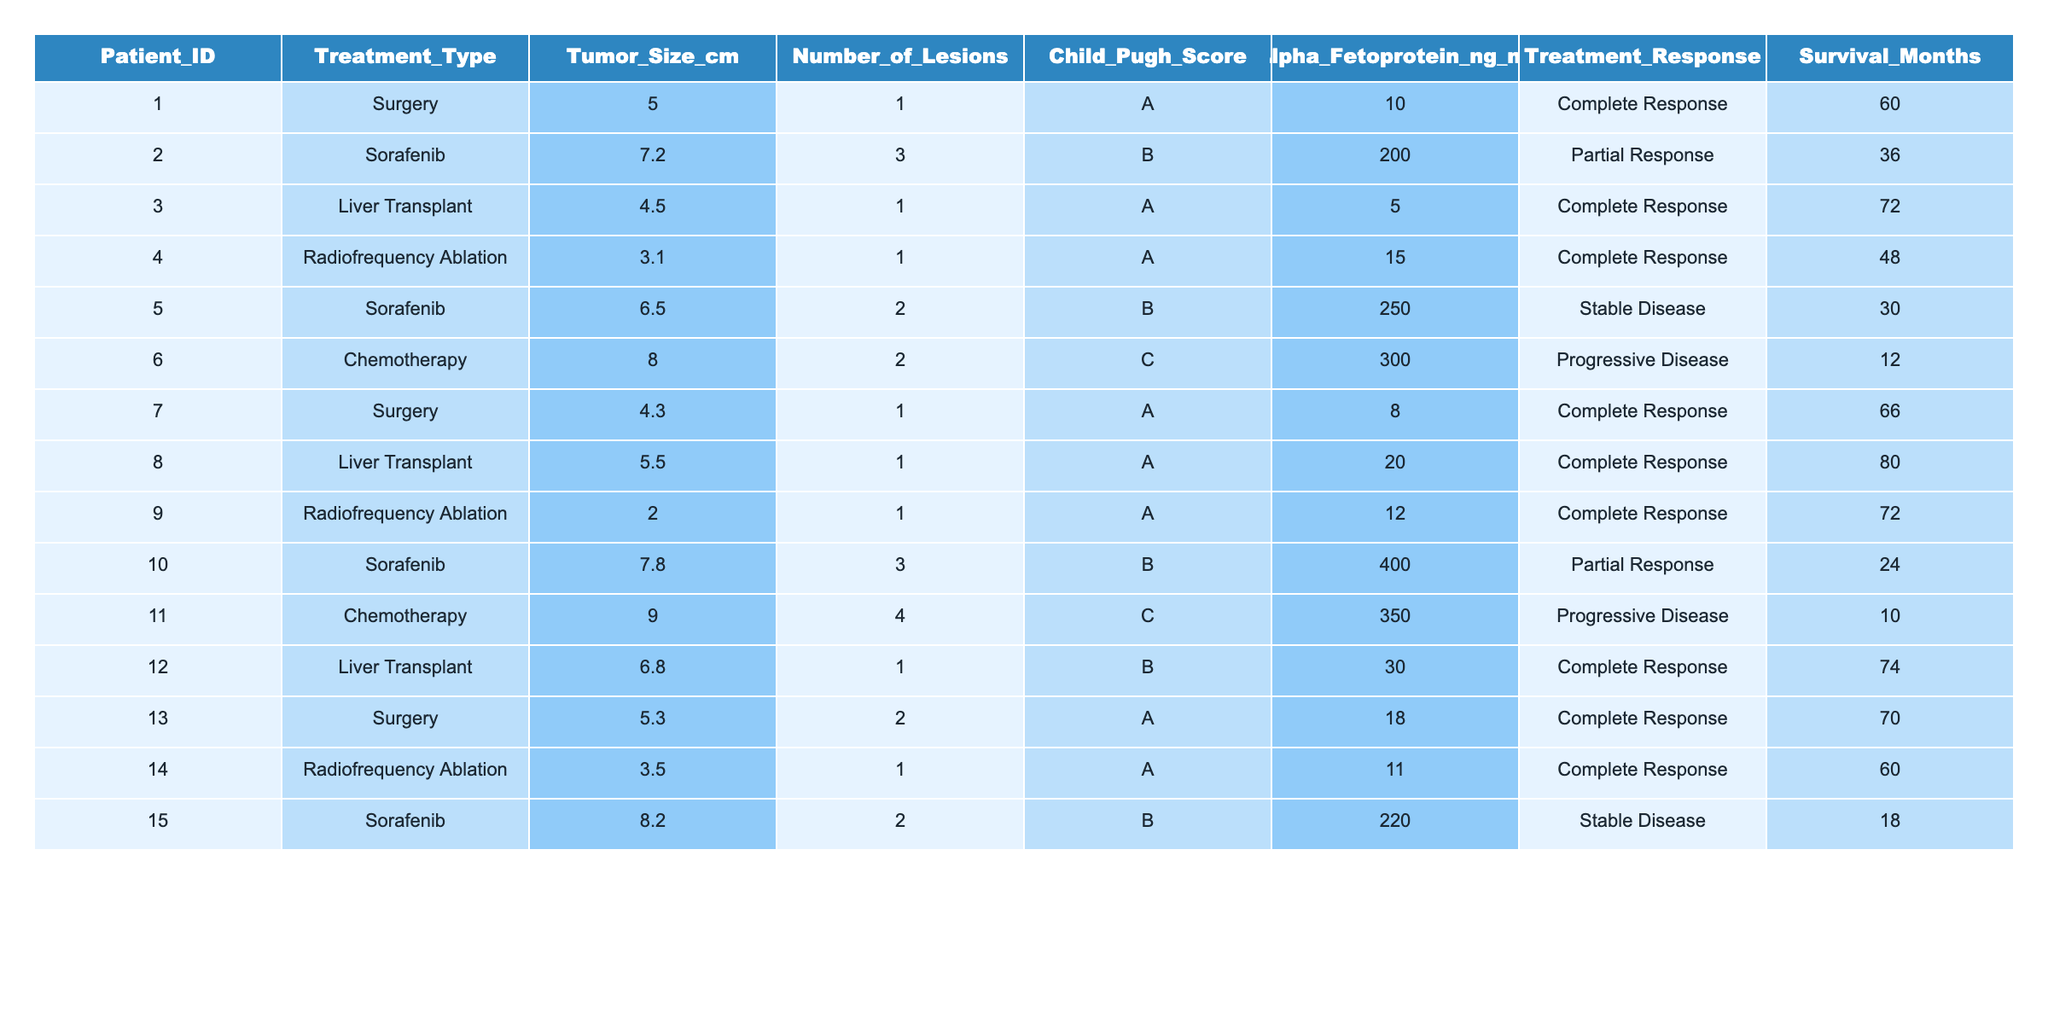What is the treatment response for Patient_ID 5? By looking at the table, I found Patient_ID 5 has a Treatment_Response listed as "Stable Disease."
Answer: Stable Disease How many patients received a liver transplant? The table shows that there are 4 entries for patients receiving "Liver Transplant" as their Treatment_Type.
Answer: 4 What is the average survival time for patients who underwent surgery? The patients who underwent surgery are identified: Patient_IDs 1, 2, 7, and 13 with survival months of 60, 36, 66, and 70 respectively. Summing these gives 60 + 36 + 66 + 70 = 232. Then, dividing by 4 (number of surgical patients) results in an average of 58.
Answer: 58 Did any patients with a Child-Pugh Score of C achieve a complete response? By examining the data in the table, I find that both patients with a Child-Pugh Score of C (Patient_IDs 6 and 11) have a Treatment_Response of "Progressive Disease," thus confirming no complete responses exist for this score.
Answer: No What is the total number of lesions among patients who received chemotherapy? The table indicates patients with chemotherapy are Patient_IDs 6 and 11, with their Number_of_Lesions recorded as 2 and 4, respectively. Summing these gives 2 + 4 = 6.
Answer: 6 Which treatment type yields the highest average survival months, and what is that average? From the table, we calculate the average survival months for each treatment type: Surgery: (60 + 66 + 70) / 3 = 65; Sorafenib: (36 + 30 + 24 + 18) / 4 = 27; Liver Transplant: (72 + 80 + 74) / 3 = 75. Radiofrequency Ablation: (48 + 72 + 60) / 3 = 60. Chemotherapy: (12 + 10) / 2 = 11. The highest average is for Liver Transplant at 75 months.
Answer: Liver Transplant, 75 How many patients had a tumor size larger than 7 cm and what were their survival months? Looking at the table, I identify 4 patients with tumor sizes larger than 7 cm: Patient_IDs 2 (36), 5 (30), 10 (24), and 15 (18). Their survival months are 36, 30, 24, and 18.
Answer: 4 patients, 36, 30, 24, 18 Is there a complete response among patients with an Alpha-Fetoprotein level greater than 100 ng/ml? Checking the table entries where the Alpha-Fetoprotein levels exceed 100 ng/ml, I see that Patients_IDs 2, 5, 10, and 11 do not have a complete response, while Patient_IDs 6 is Progressive Disease. Hence, there are no complete responses in this case.
Answer: No What is the difference in survival months between the patient with the highest and lowest survival months? The patient with the highest survival months is Patient_ID 8 with 80 months, and the lowest is Patient_ID 11 with 10 months. Therefore, the difference is 80 - 10 = 70.
Answer: 70 